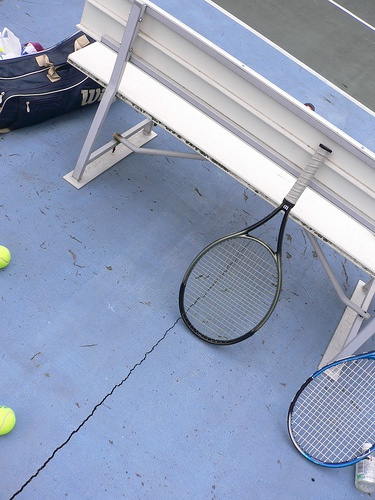Describe the objects in this image and their specific colors. I can see bench in gray, lightgray, and darkgray tones, tennis racket in gray and darkgray tones, tennis racket in gray, darkgray, and lightgray tones, handbag in gray, black, navy, and darkblue tones, and bottle in gray, darkgray, and lavender tones in this image. 